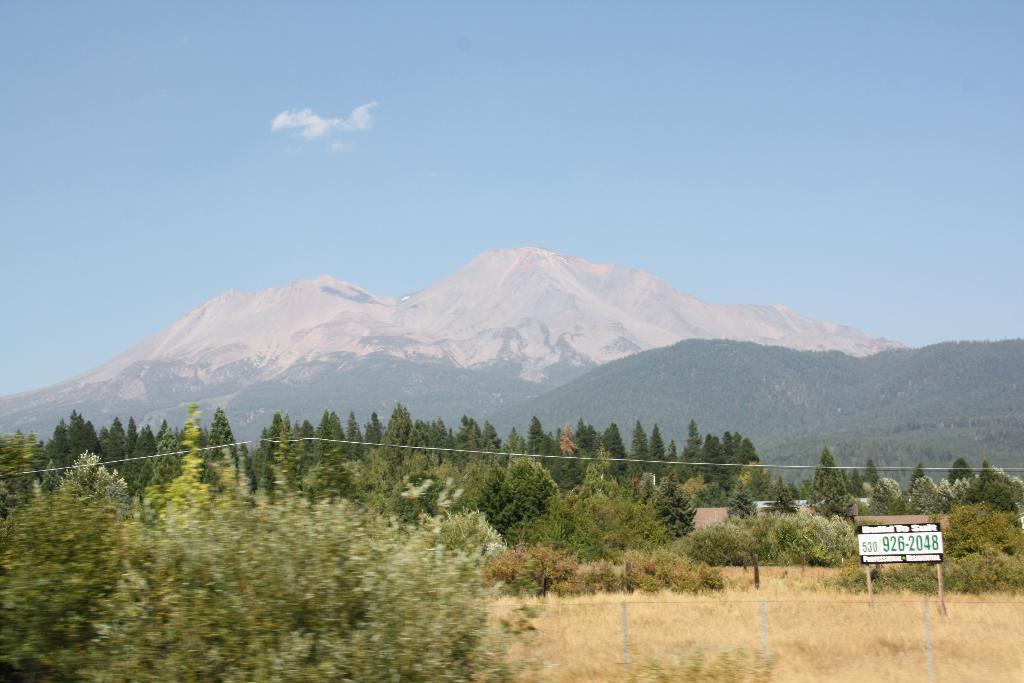Could you give a brief overview of what you see in this image? In this image we can see many trees. There is an advertising board in the image. There is a sky in the image. There are few mountains in the image. There is a fencing in the image. 